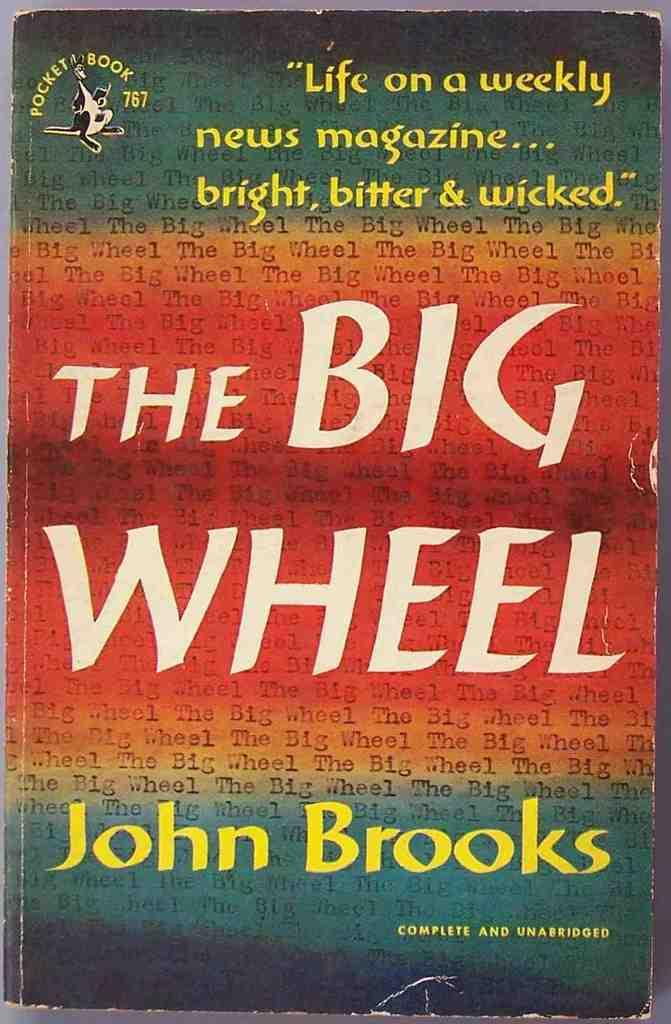Provide a one-sentence caption for the provided image. A colorful book called The Big Wheel by John Brooks. 